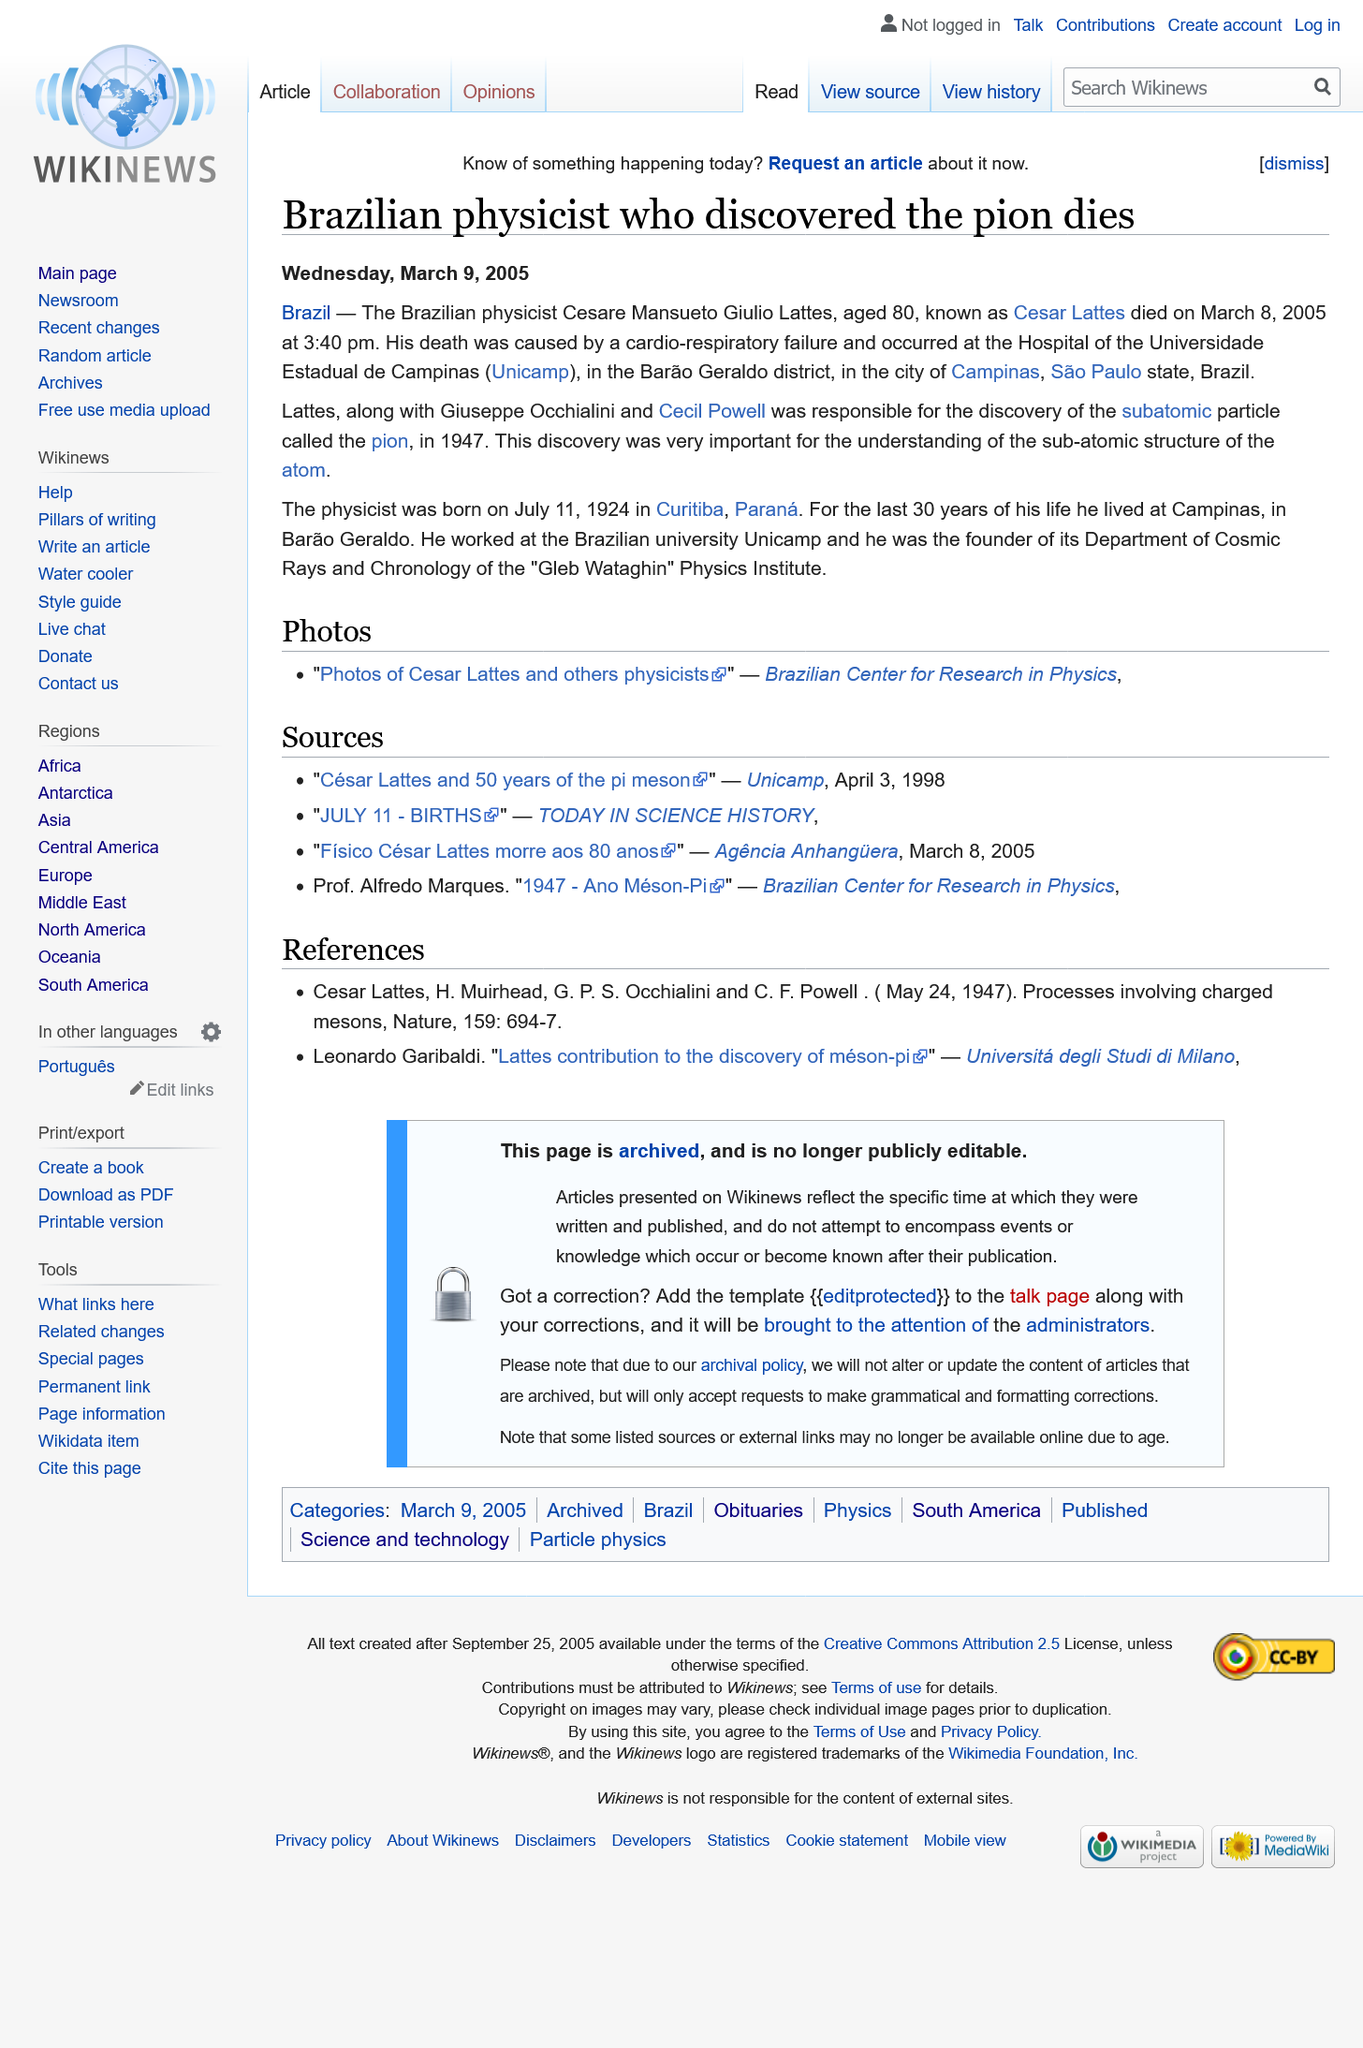Give some essential details in this illustration. The physicist was 80 years old when he passed away. The physicist was born in Curitiba, Parana. A brazilian physicist has discovered a subatomic particle called the pion. 